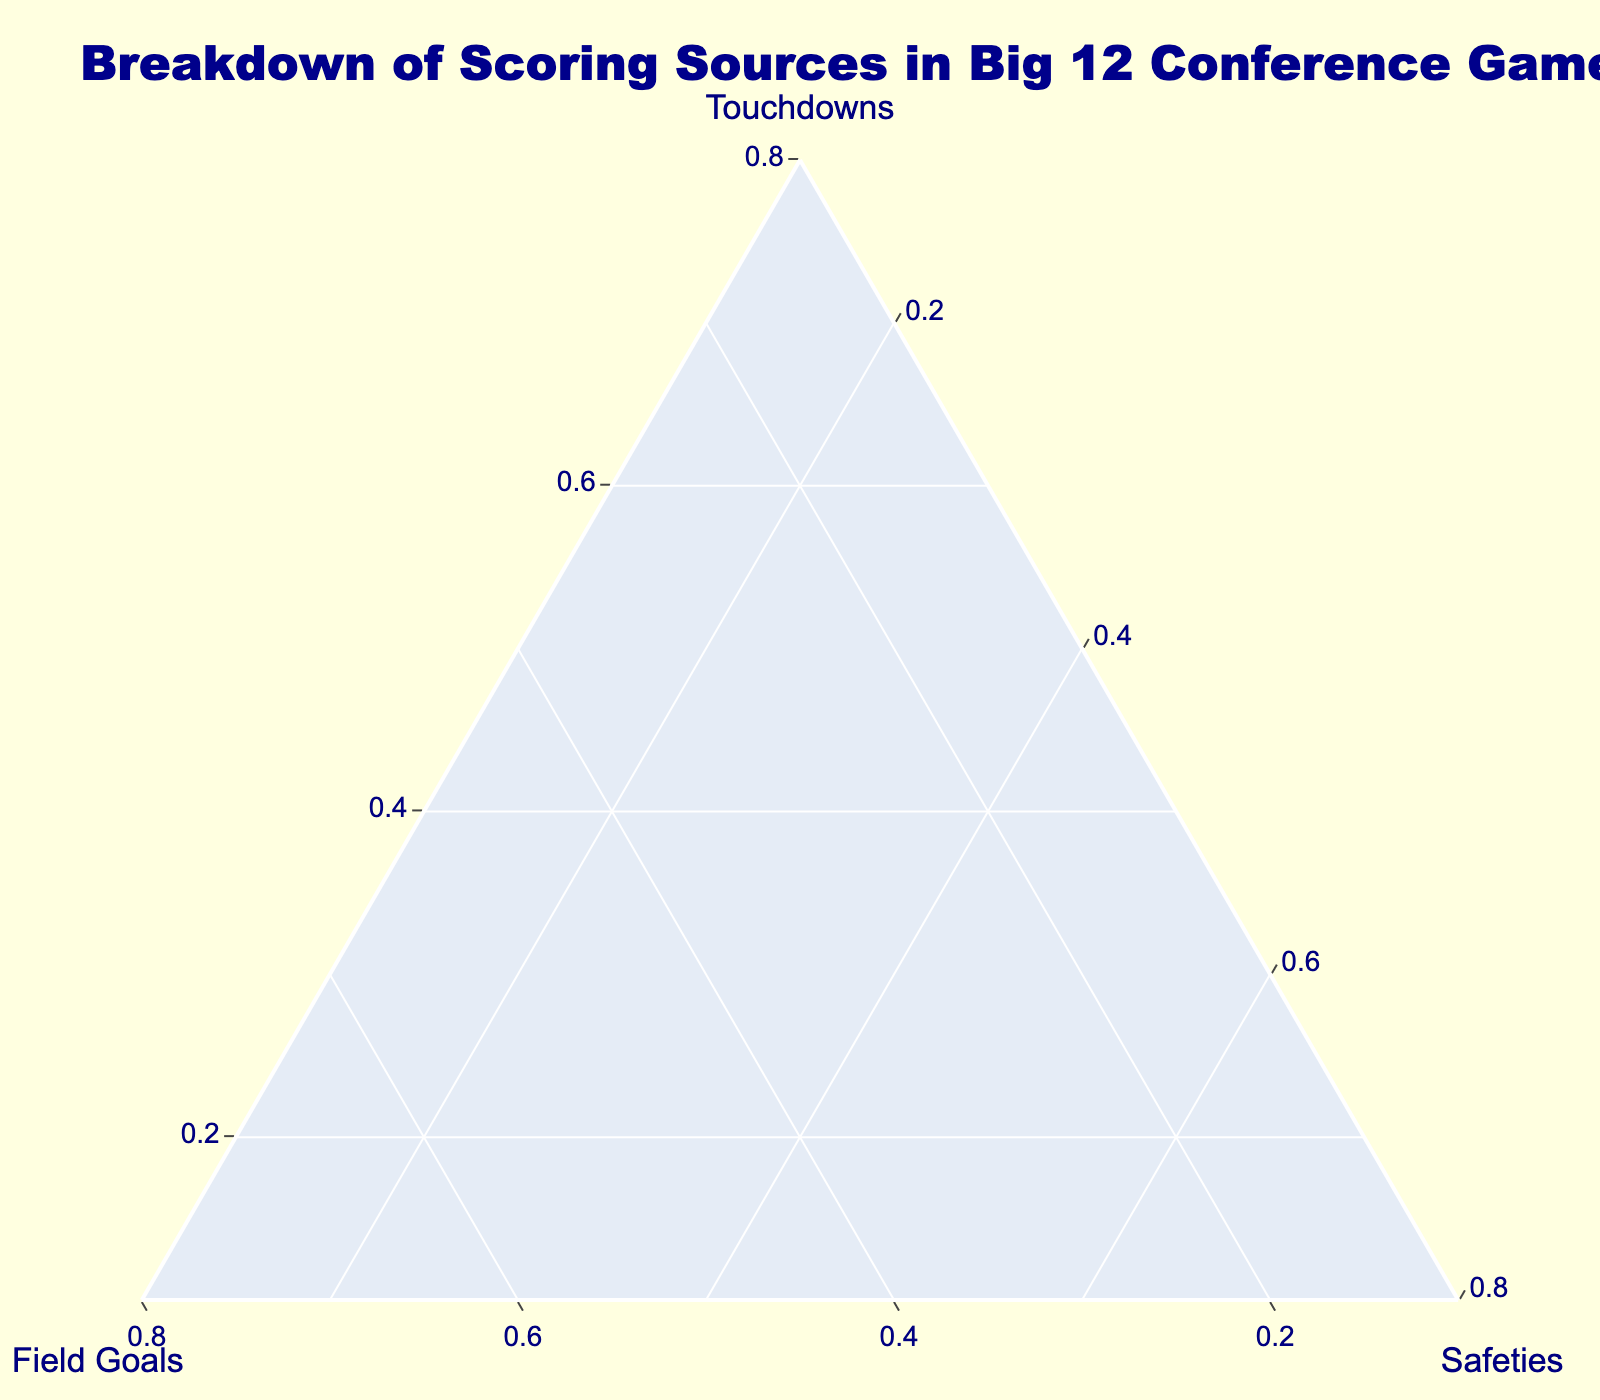What are the three scoring sources compared in the ternary plot? The ternary plot provides three axes, each representing a different scoring source. The plot shows touchdowns, field goals, and safeties for Big 12 conference games.
Answer: Touchdowns, field goals, safeties Which team has the highest percentage of touchdowns? Each team is represented as a point in the ternary plot. The team that is furthest along the 'Touchdowns' axis will have the highest percentage of touchdowns. Oklahoma is at the highest level along the touchdowns axis.
Answer: Oklahoma What is the ratio of touchdowns to field goals for Texas? For Texas, the percentages from the ternary plot need to be compared. Texas has 65 touchdowns and 30 field goals out of their total, indicating their ratio of touchdowns to field goals should be calculated as 65:30.
Answer: 65:30 Which team has the lowest percentage of field goals? The team that is positioned lowest along the 'Field Goals' axis will exhibit the lowest percentage of field goals. Oklahoma, being positioned at the lowest level for field goals, is our answer.
Answer: Oklahoma Between Iowa State and Baylor, which team relies more on field goals? Comparing the positions of Iowa State and Baylor along the 'Field Goals' axis in the ternary plot, Iowa State is positioned further along the field goals axis than Baylor.
Answer: Iowa State What is the median percentage of touchdowns across all teams? To calculate the median, first find the percentage of touchdowns for each team. Then sort these percentages and select the middle value. After normalization, the sorted percentages for touchdowns are 0.11, 0.14, 0.17, 0.2, 0.23, 0.26, 0.29, 0.32, 0.35, 0.38. The middle values are 0.23 and 0.26, and their average is the median.
Answer: 0.245 Which team has an equal percentage for touchdowns and field goals? By observing the ternary plot, the team at an equal distance from the 'Touchdowns' and 'Field Goals' axes will have equal percentages. Texas Ice right at that spot.
Answer: Texas What is the percentage of safeties for Kansas? On the ternary plot, the safeties value for Kansas remains constant and positioned at one spot. Each team has a relatively small but consistent representation for safeties.
Answer: 5% Which team has the second-lowest percentage of touchdowns? In the ternary plot, the touchdown percentage for each team should be identified and compared. The second last team, Kansas, holds 25% touchdowns.
Answer: Kansas 